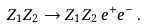Convert formula to latex. <formula><loc_0><loc_0><loc_500><loc_500>Z _ { 1 } Z _ { 2 } \to Z _ { 1 } Z _ { 2 } \, e ^ { + } e ^ { - } \, .</formula> 